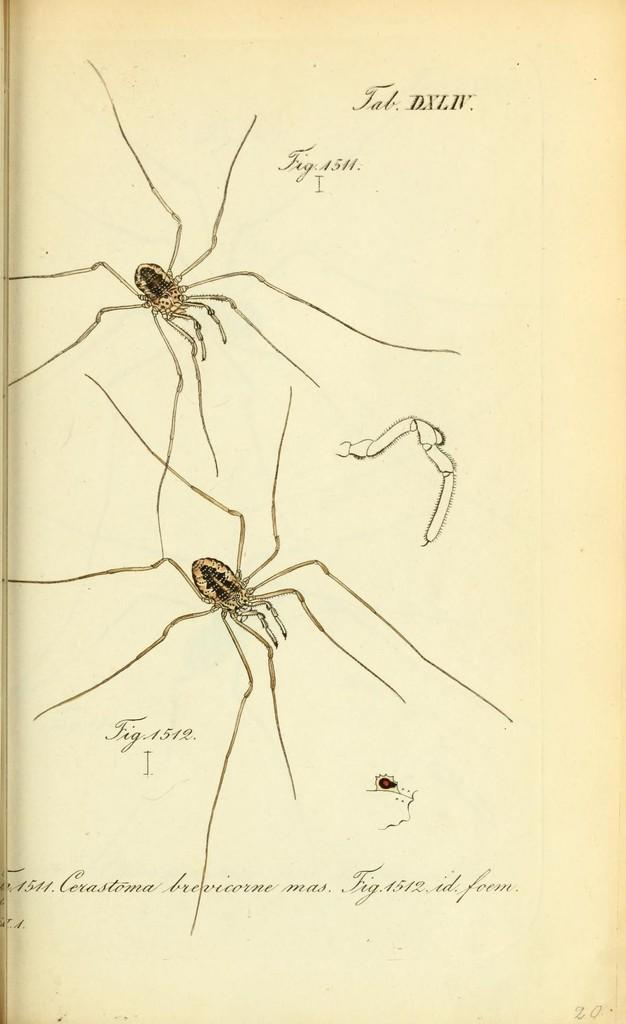How many insects are present in the image? There are two insects in the image. What is written above and below the insects? There is text written above and below the insects. Can you see any curtains in the image? There are no curtains present in the image. 